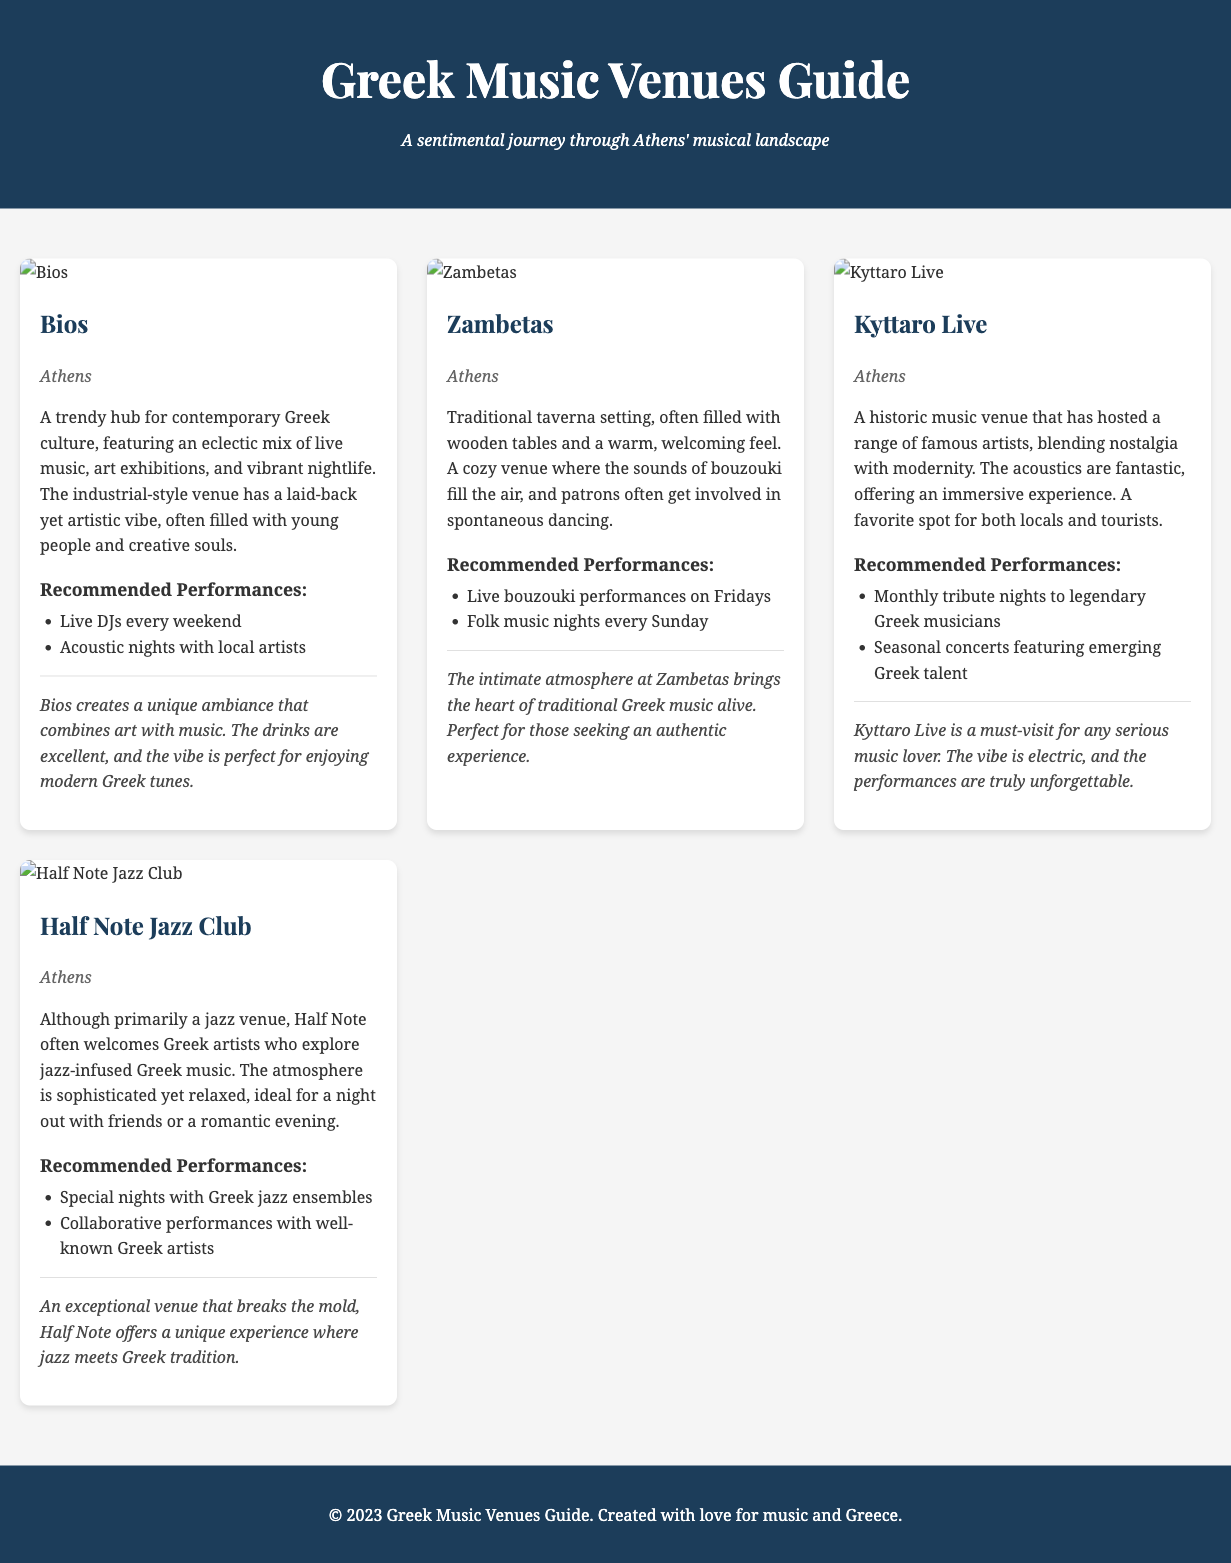What is the name of the first venue listed? The first venue listed in the document is titled "Bios."
Answer: Bios What type of performances are recommended at Zambetas? The recommended performances include live bouzouki performances on Fridays and folk music nights every Sunday.
Answer: Live bouzouki performances on Fridays Which venue features a sophisticated yet relaxed atmosphere? The venue that features a sophisticated yet relaxed atmosphere is Half Note Jazz Club.
Answer: Half Note Jazz Club How many venues are mentioned in the document? The document mentions four venues in total: Bios, Zambetas, Kyttaro Live, and Half Note Jazz Club.
Answer: Four What is a unique feature of Kyttaro Live? Kyttaro Live is noted for its fantastic acoustics, offering an immersive experience.
Answer: Fantastic acoustics What style of music is primarily featured at Half Note? Although it is primarily a jazz venue, it often welcomes Greek artists who explore jazz-infused Greek music.
Answer: Jazz What is the ambiance of Zambetas like? Zambetas has a cozy atmosphere filled with wooden tables and a warm, welcoming feel.
Answer: Cozy atmosphere Which venue is described as a trendy hub for contemporary Greek culture? The venue described as a trendy hub for contemporary Greek culture is Bios.
Answer: Bios What is the subtitle of the document? The subtitle of the document is "A sentimental journey through Athens' musical landscape."
Answer: A sentimental journey through Athens' musical landscape 